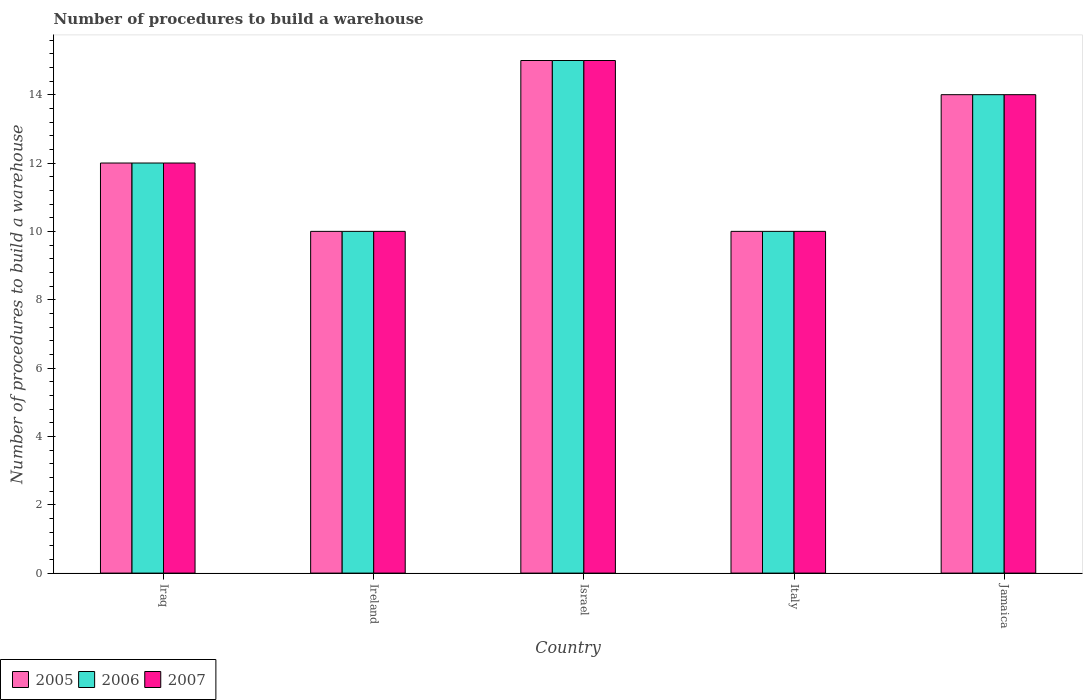Are the number of bars per tick equal to the number of legend labels?
Provide a short and direct response. Yes. Are the number of bars on each tick of the X-axis equal?
Offer a terse response. Yes. What is the label of the 2nd group of bars from the left?
Your answer should be compact. Ireland. What is the number of procedures to build a warehouse in in 2006 in Israel?
Offer a very short reply. 15. Across all countries, what is the maximum number of procedures to build a warehouse in in 2007?
Your response must be concise. 15. In which country was the number of procedures to build a warehouse in in 2007 maximum?
Provide a succinct answer. Israel. In which country was the number of procedures to build a warehouse in in 2007 minimum?
Your response must be concise. Ireland. What is the difference between the number of procedures to build a warehouse in in 2005 in Jamaica and the number of procedures to build a warehouse in in 2007 in Iraq?
Offer a very short reply. 2. Is the number of procedures to build a warehouse in in 2005 in Ireland less than that in Italy?
Provide a succinct answer. No. What is the difference between the highest and the second highest number of procedures to build a warehouse in in 2005?
Your answer should be compact. -2. What is the difference between the highest and the lowest number of procedures to build a warehouse in in 2007?
Your answer should be very brief. 5. What does the 3rd bar from the right in Italy represents?
Your answer should be compact. 2005. Is it the case that in every country, the sum of the number of procedures to build a warehouse in in 2006 and number of procedures to build a warehouse in in 2005 is greater than the number of procedures to build a warehouse in in 2007?
Keep it short and to the point. Yes. How many countries are there in the graph?
Give a very brief answer. 5. How many legend labels are there?
Offer a terse response. 3. What is the title of the graph?
Ensure brevity in your answer.  Number of procedures to build a warehouse. What is the label or title of the X-axis?
Your answer should be compact. Country. What is the label or title of the Y-axis?
Give a very brief answer. Number of procedures to build a warehouse. What is the Number of procedures to build a warehouse in 2007 in Iraq?
Your response must be concise. 12. What is the Number of procedures to build a warehouse of 2005 in Ireland?
Your answer should be very brief. 10. What is the Number of procedures to build a warehouse of 2006 in Israel?
Give a very brief answer. 15. What is the Number of procedures to build a warehouse in 2005 in Italy?
Keep it short and to the point. 10. What is the Number of procedures to build a warehouse of 2006 in Italy?
Offer a very short reply. 10. What is the Number of procedures to build a warehouse in 2005 in Jamaica?
Keep it short and to the point. 14. What is the Number of procedures to build a warehouse of 2007 in Jamaica?
Ensure brevity in your answer.  14. Across all countries, what is the maximum Number of procedures to build a warehouse of 2005?
Make the answer very short. 15. Across all countries, what is the maximum Number of procedures to build a warehouse in 2006?
Offer a very short reply. 15. Across all countries, what is the maximum Number of procedures to build a warehouse in 2007?
Make the answer very short. 15. Across all countries, what is the minimum Number of procedures to build a warehouse of 2007?
Your response must be concise. 10. What is the total Number of procedures to build a warehouse of 2007 in the graph?
Provide a succinct answer. 61. What is the difference between the Number of procedures to build a warehouse of 2005 in Iraq and that in Ireland?
Give a very brief answer. 2. What is the difference between the Number of procedures to build a warehouse of 2006 in Iraq and that in Israel?
Offer a terse response. -3. What is the difference between the Number of procedures to build a warehouse in 2007 in Iraq and that in Israel?
Offer a terse response. -3. What is the difference between the Number of procedures to build a warehouse in 2007 in Iraq and that in Italy?
Make the answer very short. 2. What is the difference between the Number of procedures to build a warehouse of 2006 in Ireland and that in Israel?
Your response must be concise. -5. What is the difference between the Number of procedures to build a warehouse of 2007 in Ireland and that in Israel?
Provide a succinct answer. -5. What is the difference between the Number of procedures to build a warehouse in 2005 in Ireland and that in Italy?
Make the answer very short. 0. What is the difference between the Number of procedures to build a warehouse of 2006 in Ireland and that in Jamaica?
Your answer should be compact. -4. What is the difference between the Number of procedures to build a warehouse in 2005 in Israel and that in Jamaica?
Provide a short and direct response. 1. What is the difference between the Number of procedures to build a warehouse of 2006 in Israel and that in Jamaica?
Give a very brief answer. 1. What is the difference between the Number of procedures to build a warehouse in 2005 in Italy and that in Jamaica?
Ensure brevity in your answer.  -4. What is the difference between the Number of procedures to build a warehouse of 2006 in Italy and that in Jamaica?
Keep it short and to the point. -4. What is the difference between the Number of procedures to build a warehouse in 2005 in Iraq and the Number of procedures to build a warehouse in 2007 in Ireland?
Keep it short and to the point. 2. What is the difference between the Number of procedures to build a warehouse of 2006 in Iraq and the Number of procedures to build a warehouse of 2007 in Ireland?
Your response must be concise. 2. What is the difference between the Number of procedures to build a warehouse of 2005 in Iraq and the Number of procedures to build a warehouse of 2006 in Israel?
Offer a very short reply. -3. What is the difference between the Number of procedures to build a warehouse of 2006 in Iraq and the Number of procedures to build a warehouse of 2007 in Israel?
Your response must be concise. -3. What is the difference between the Number of procedures to build a warehouse of 2005 in Iraq and the Number of procedures to build a warehouse of 2007 in Italy?
Keep it short and to the point. 2. What is the difference between the Number of procedures to build a warehouse of 2006 in Iraq and the Number of procedures to build a warehouse of 2007 in Italy?
Make the answer very short. 2. What is the difference between the Number of procedures to build a warehouse in 2005 in Iraq and the Number of procedures to build a warehouse in 2007 in Jamaica?
Provide a short and direct response. -2. What is the difference between the Number of procedures to build a warehouse of 2006 in Iraq and the Number of procedures to build a warehouse of 2007 in Jamaica?
Your answer should be compact. -2. What is the difference between the Number of procedures to build a warehouse in 2005 in Ireland and the Number of procedures to build a warehouse in 2006 in Israel?
Your answer should be compact. -5. What is the difference between the Number of procedures to build a warehouse in 2005 in Ireland and the Number of procedures to build a warehouse in 2007 in Italy?
Offer a very short reply. 0. What is the difference between the Number of procedures to build a warehouse in 2005 in Ireland and the Number of procedures to build a warehouse in 2006 in Jamaica?
Offer a terse response. -4. What is the difference between the Number of procedures to build a warehouse in 2005 in Ireland and the Number of procedures to build a warehouse in 2007 in Jamaica?
Your response must be concise. -4. What is the difference between the Number of procedures to build a warehouse of 2006 in Israel and the Number of procedures to build a warehouse of 2007 in Italy?
Make the answer very short. 5. What is the difference between the Number of procedures to build a warehouse in 2006 in Israel and the Number of procedures to build a warehouse in 2007 in Jamaica?
Ensure brevity in your answer.  1. What is the difference between the Number of procedures to build a warehouse in 2005 in Italy and the Number of procedures to build a warehouse in 2007 in Jamaica?
Your answer should be very brief. -4. What is the average Number of procedures to build a warehouse of 2006 per country?
Your answer should be very brief. 12.2. What is the difference between the Number of procedures to build a warehouse of 2005 and Number of procedures to build a warehouse of 2006 in Iraq?
Ensure brevity in your answer.  0. What is the difference between the Number of procedures to build a warehouse of 2006 and Number of procedures to build a warehouse of 2007 in Iraq?
Provide a short and direct response. 0. What is the difference between the Number of procedures to build a warehouse in 2005 and Number of procedures to build a warehouse in 2006 in Israel?
Offer a very short reply. 0. What is the difference between the Number of procedures to build a warehouse in 2006 and Number of procedures to build a warehouse in 2007 in Israel?
Provide a short and direct response. 0. What is the difference between the Number of procedures to build a warehouse of 2005 and Number of procedures to build a warehouse of 2007 in Jamaica?
Your answer should be very brief. 0. What is the ratio of the Number of procedures to build a warehouse in 2005 in Iraq to that in Ireland?
Your answer should be compact. 1.2. What is the ratio of the Number of procedures to build a warehouse in 2006 in Iraq to that in Ireland?
Give a very brief answer. 1.2. What is the ratio of the Number of procedures to build a warehouse in 2007 in Iraq to that in Ireland?
Offer a very short reply. 1.2. What is the ratio of the Number of procedures to build a warehouse in 2006 in Iraq to that in Israel?
Offer a terse response. 0.8. What is the ratio of the Number of procedures to build a warehouse of 2007 in Iraq to that in Israel?
Ensure brevity in your answer.  0.8. What is the ratio of the Number of procedures to build a warehouse of 2005 in Iraq to that in Italy?
Make the answer very short. 1.2. What is the ratio of the Number of procedures to build a warehouse of 2006 in Iraq to that in Italy?
Provide a succinct answer. 1.2. What is the ratio of the Number of procedures to build a warehouse in 2005 in Iraq to that in Jamaica?
Offer a very short reply. 0.86. What is the ratio of the Number of procedures to build a warehouse of 2006 in Iraq to that in Jamaica?
Offer a very short reply. 0.86. What is the ratio of the Number of procedures to build a warehouse of 2007 in Iraq to that in Jamaica?
Make the answer very short. 0.86. What is the ratio of the Number of procedures to build a warehouse in 2006 in Ireland to that in Israel?
Your answer should be compact. 0.67. What is the ratio of the Number of procedures to build a warehouse of 2006 in Ireland to that in Italy?
Make the answer very short. 1. What is the ratio of the Number of procedures to build a warehouse in 2007 in Ireland to that in Italy?
Offer a very short reply. 1. What is the ratio of the Number of procedures to build a warehouse of 2007 in Ireland to that in Jamaica?
Your answer should be compact. 0.71. What is the ratio of the Number of procedures to build a warehouse in 2005 in Israel to that in Jamaica?
Offer a very short reply. 1.07. What is the ratio of the Number of procedures to build a warehouse in 2006 in Israel to that in Jamaica?
Give a very brief answer. 1.07. What is the ratio of the Number of procedures to build a warehouse of 2007 in Israel to that in Jamaica?
Provide a short and direct response. 1.07. What is the ratio of the Number of procedures to build a warehouse of 2005 in Italy to that in Jamaica?
Offer a terse response. 0.71. What is the ratio of the Number of procedures to build a warehouse in 2007 in Italy to that in Jamaica?
Your answer should be very brief. 0.71. What is the difference between the highest and the second highest Number of procedures to build a warehouse of 2006?
Your answer should be compact. 1. What is the difference between the highest and the second highest Number of procedures to build a warehouse of 2007?
Your answer should be compact. 1. What is the difference between the highest and the lowest Number of procedures to build a warehouse of 2005?
Keep it short and to the point. 5. 